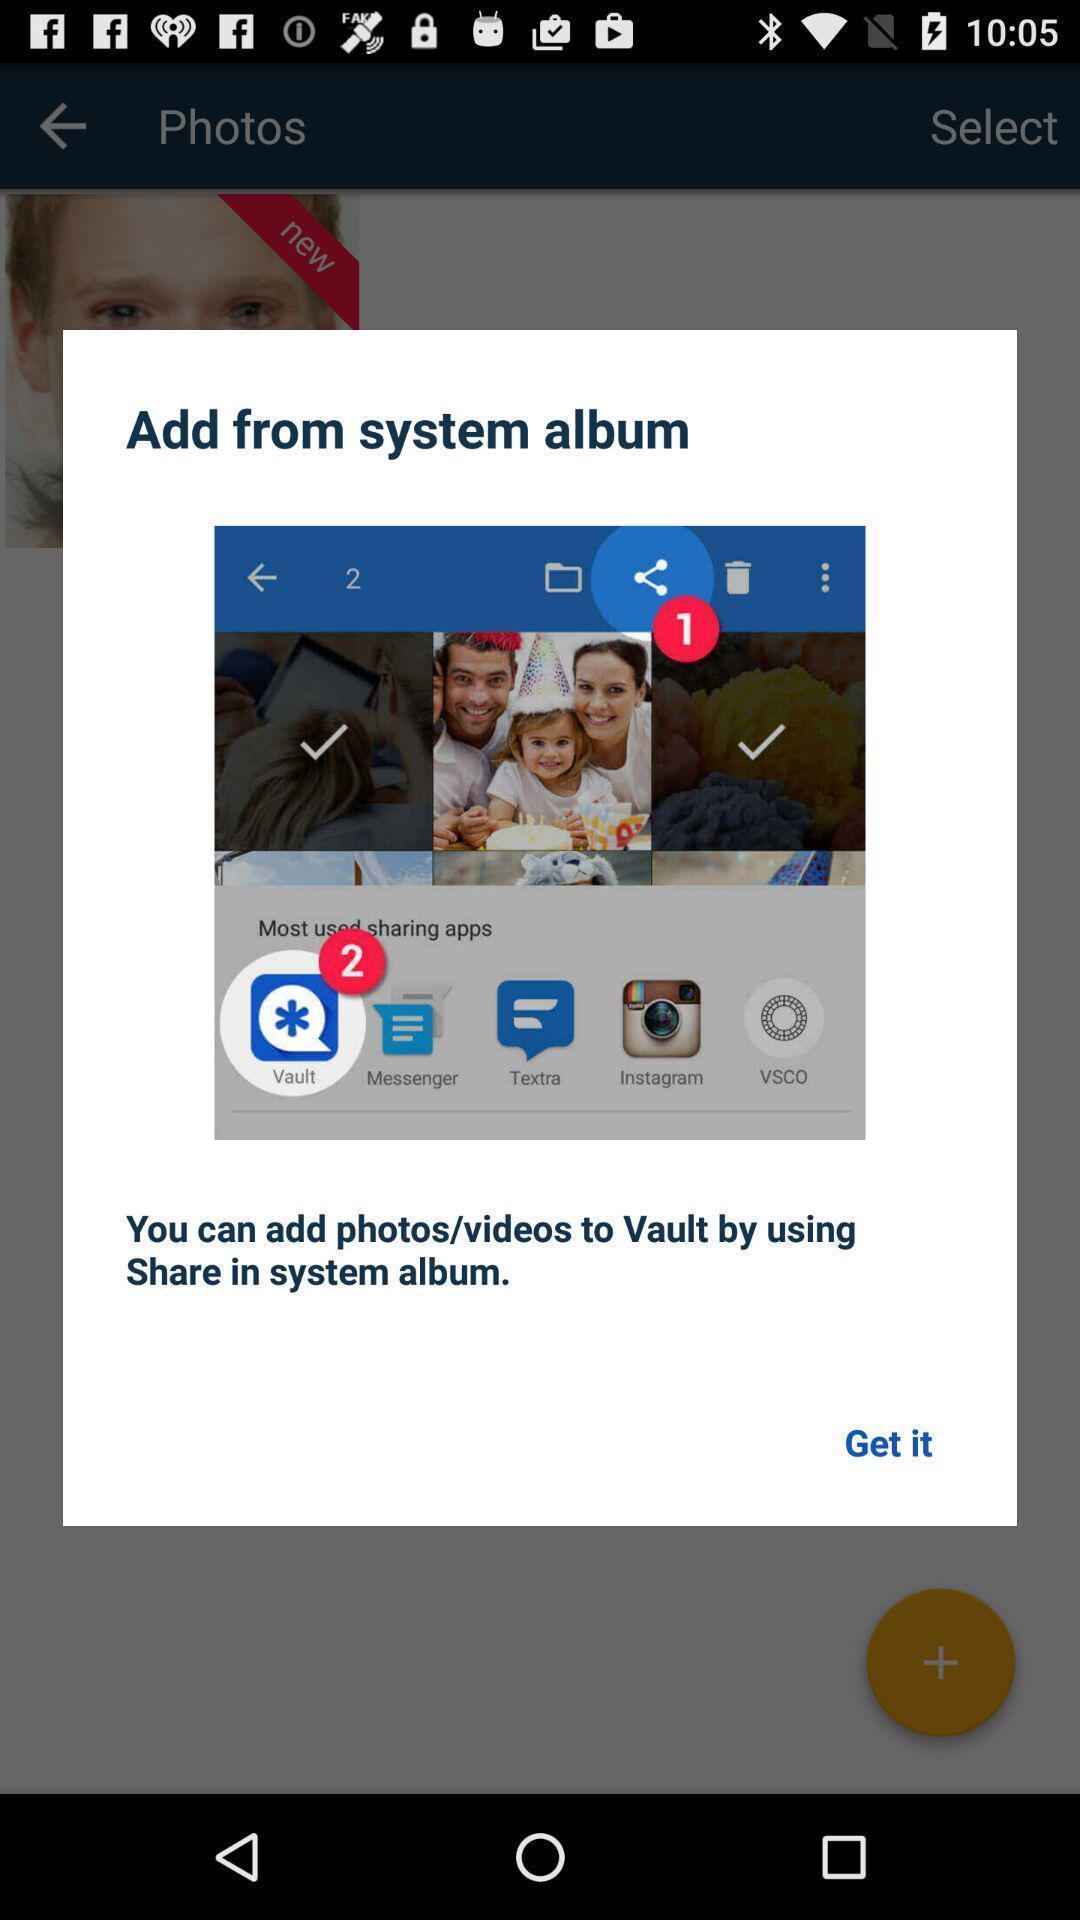Give me a narrative description of this picture. Popup showing information to add from system album. 